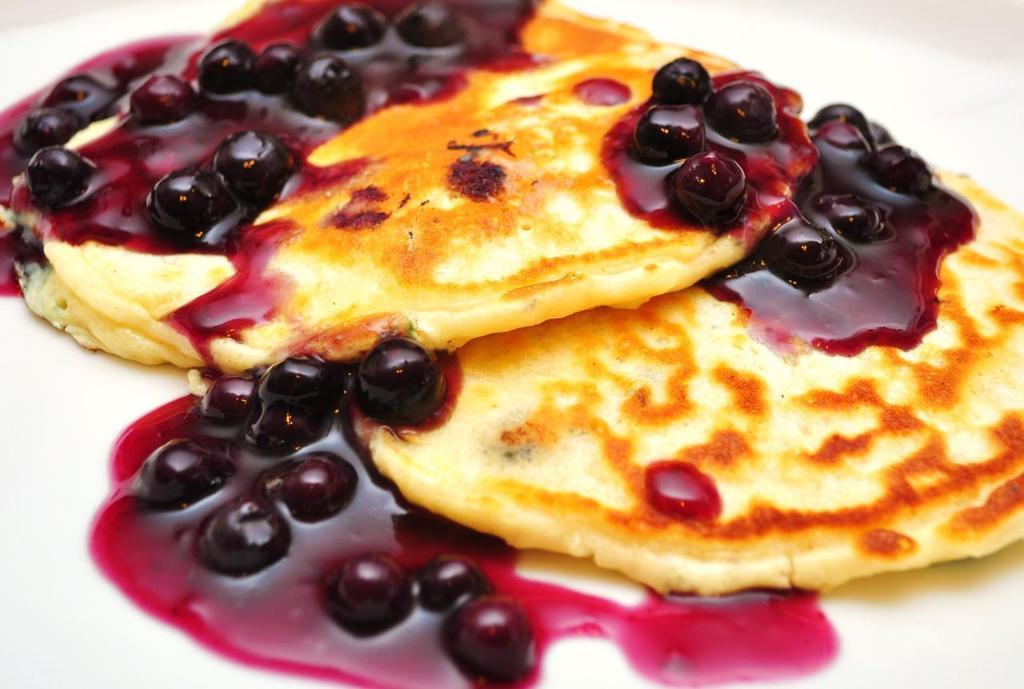What type of food is shown in the image? There are two pancakes in the image. What is on top of the pancakes? The pancakes have blueberry jam on them. What color is the background of the image? The background of the image appears to be white in color. What is the chance of winning a lottery in the image? There is no mention of a lottery or any chance of winning in the image. 